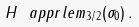<formula> <loc_0><loc_0><loc_500><loc_500>H \ a p p r l e m _ { 3 / 2 } ( \sigma _ { 0 } ) \, .</formula> 